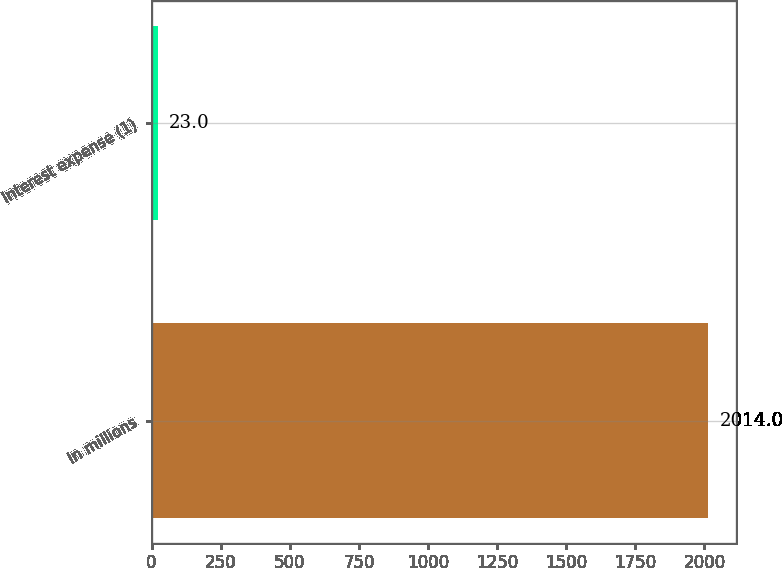Convert chart. <chart><loc_0><loc_0><loc_500><loc_500><bar_chart><fcel>In millions<fcel>Interest expense (1)<nl><fcel>2014<fcel>23<nl></chart> 